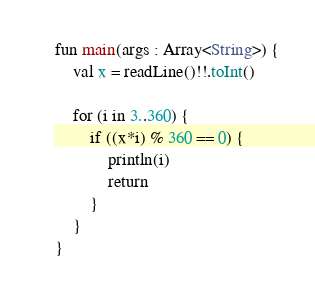<code> <loc_0><loc_0><loc_500><loc_500><_Kotlin_>fun main(args : Array<String>) {
    val x = readLine()!!.toInt()

    for (i in 3..360) {
        if ((x*i) % 360 == 0) {
            println(i)
            return
        }
    }
}</code> 